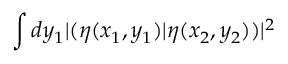Convert formula to latex. <formula><loc_0><loc_0><loc_500><loc_500>\int d y _ { 1 } | ( \eta ( x _ { 1 } , y _ { 1 } ) | \eta ( x _ { 2 } , y _ { 2 } ) ) | ^ { 2 }</formula> 